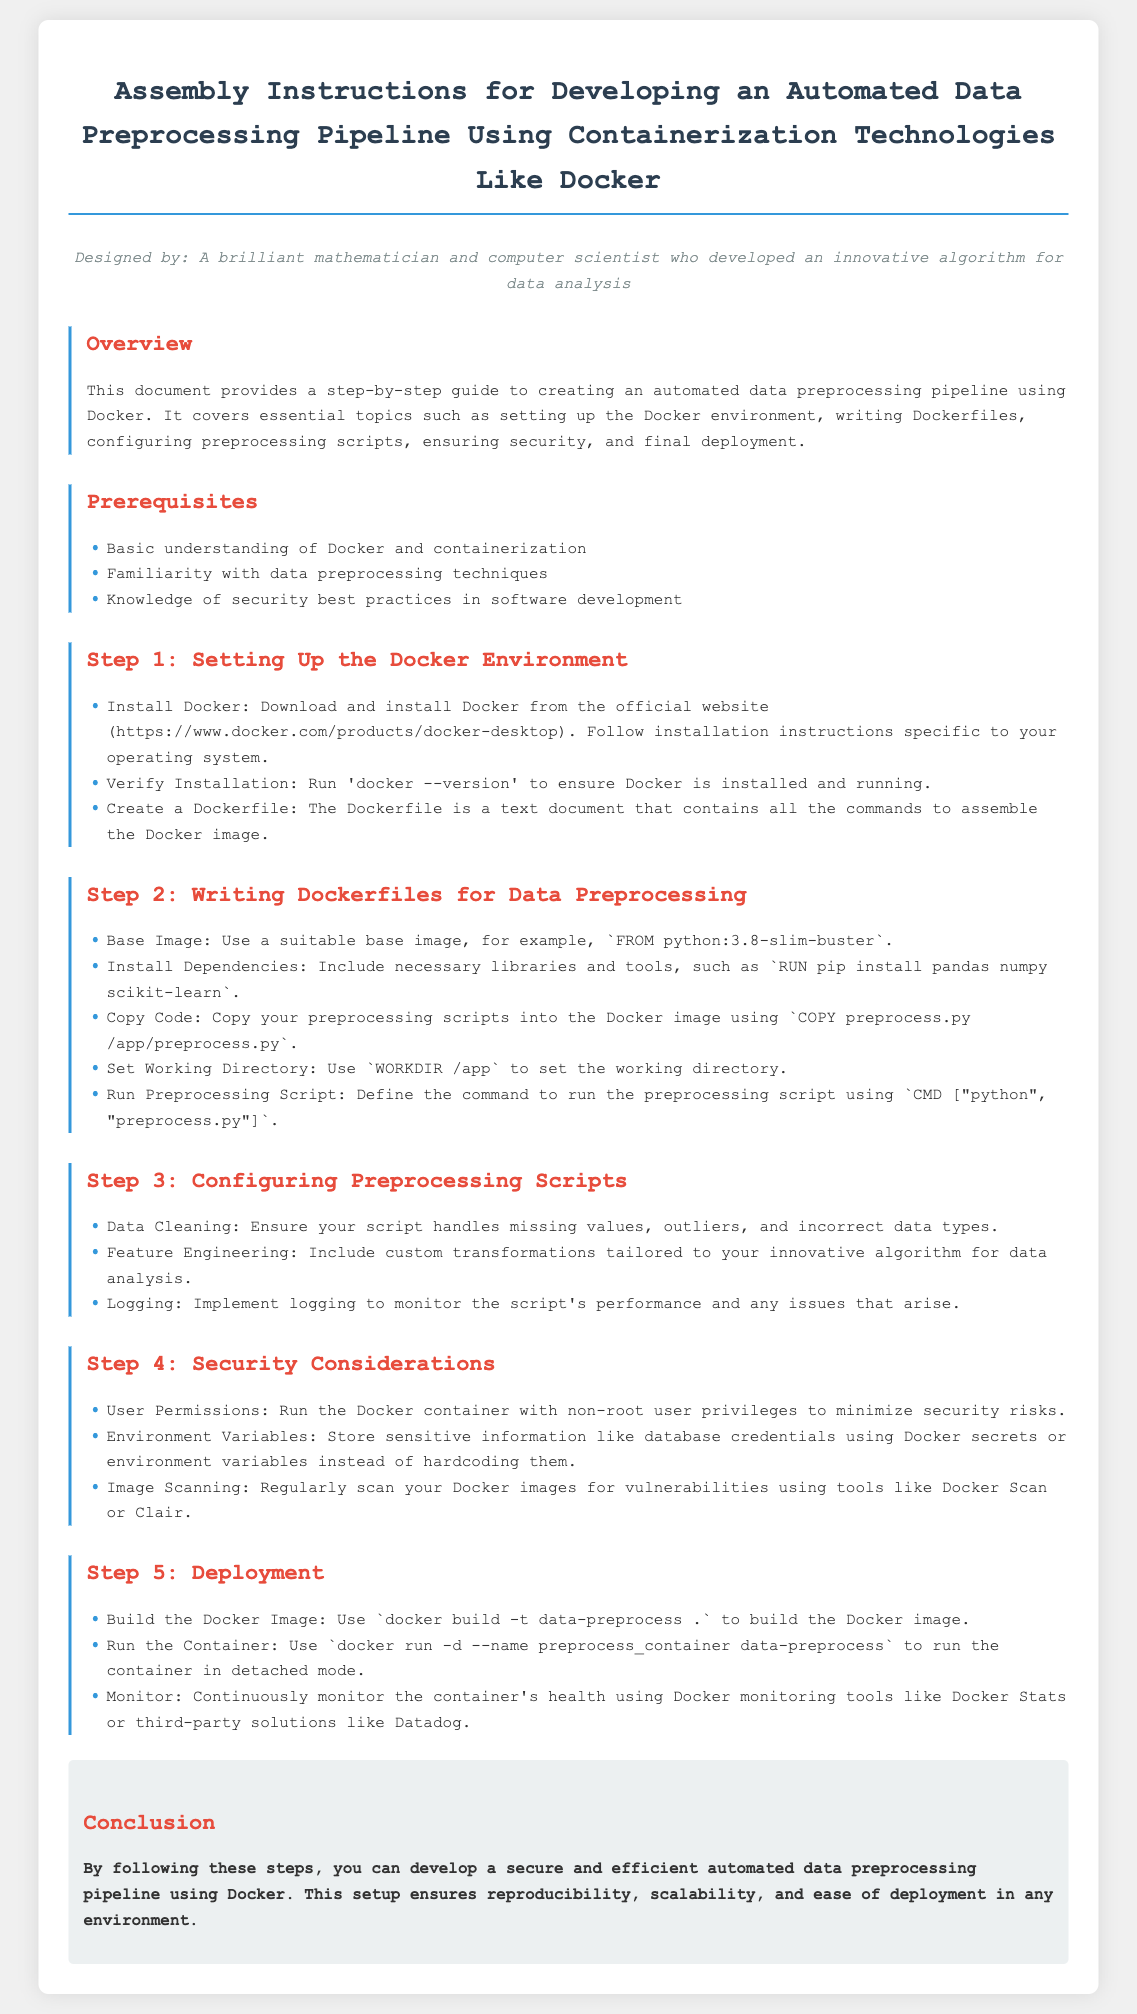What is the title of the document? The title is located in the header section and describes the core subject of the document.
Answer: Automated Data Preprocessing Pipeline Assembly Instructions Who is the document designed by? The designer is identified in the persona section, which provides context about the author's expertise.
Answer: A brilliant mathematician and computer scientist who developed an innovative algorithm for data analysis What is the first step in setting up the pipeline? The first step listed in the document is included in the step-by-step guide related to environment setup.
Answer: Setting Up the Docker Environment Which programming language is mentioned for the base image? The base image specified in the Dockerfile section indicates the programming language used.
Answer: Python What should be run to verify the Docker installation? The specific command to ensure Docker has been correctly installed is provided in the instructions.
Answer: docker --version How many prerequisites are listed? The number of prerequisites can be found by counting the items in the corresponding section of the document.
Answer: Three What should be used to store sensitive information? The document discusses security measures and mentions methods for handling sensitive data.
Answer: Docker secrets What command is used to build the Docker image? The command for building the Docker image is provided in the deployment section.
Answer: docker build -t data-preprocess  What should the preprocessing script handle? The document advises on specific functions the script should manage, highlighting important preprocessing tasks.
Answer: Missing values, outliers, and incorrect data types 